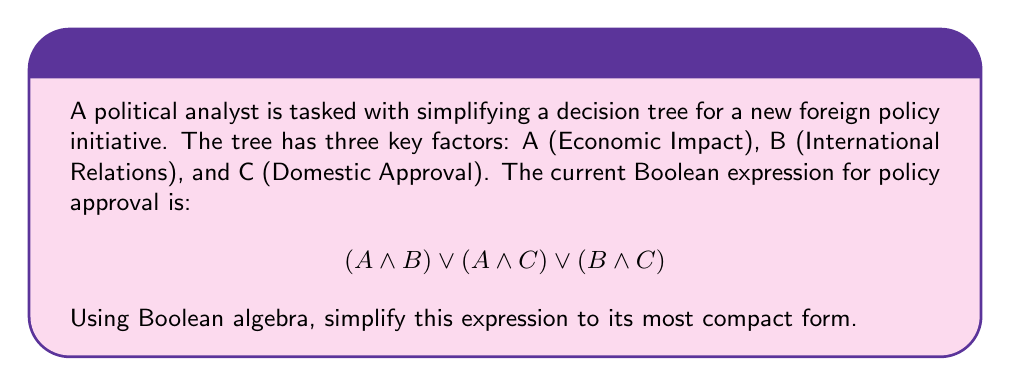Could you help me with this problem? Let's simplify this expression step-by-step using Boolean algebra laws:

1) First, we can recognize this as a form of the consensus theorem, which states:
   $$(X \land Y) \lor (X \land Z) \lor (Y \land Z) = (X \land Y) \lor (Y \land Z)$$

2) Applying this directly to our expression:
   $$(A \land B) \lor (A \land C) \lor (B \land C) = (A \land B) \lor (B \land C)$$

3) Now we have a simpler expression: $(A \land B) \lor (B \land C)$

4) We can factor out the common term B:
   $B \land (A \lor C)$

5) This is the most simplified form of the original expression.

In political terms, this simplification suggests that factor B (International Relations) is crucial for policy approval, and it must be combined with either A (Economic Impact) or C (Domestic Approval).
Answer: $B \land (A \lor C)$ 